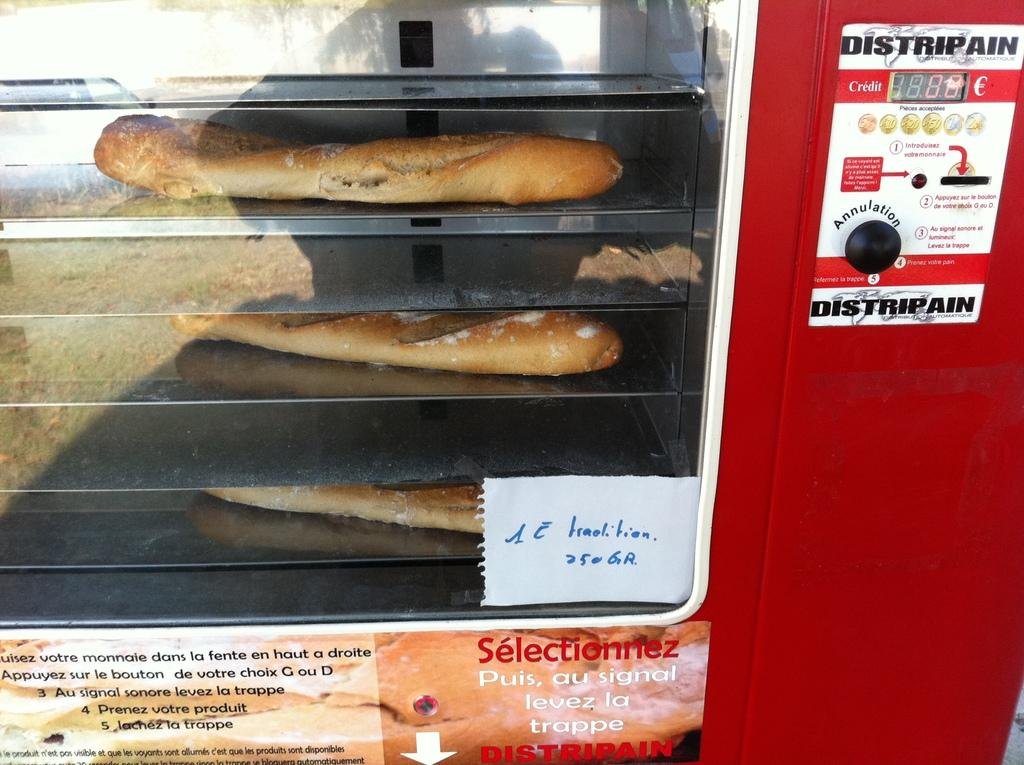What is the main object in the image? There is a vending machine in the image. What can be seen inside the vending machine? There is food visible in the image. Is there any text present in the image? Yes, there is text at the bottom of the image. What type of stem can be seen growing from the notebook in the image? There is no notebook or stem present in the image; it features a vending machine with food and text at the bottom. 